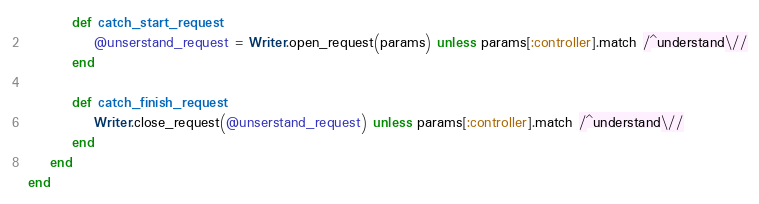<code> <loc_0><loc_0><loc_500><loc_500><_Ruby_>
		def catch_start_request
			@unserstand_request = Writer.open_request(params) unless params[:controller].match /^understand\//
		end

		def catch_finish_request
			Writer.close_request(@unserstand_request) unless params[:controller].match /^understand\//
		end
	end
end</code> 